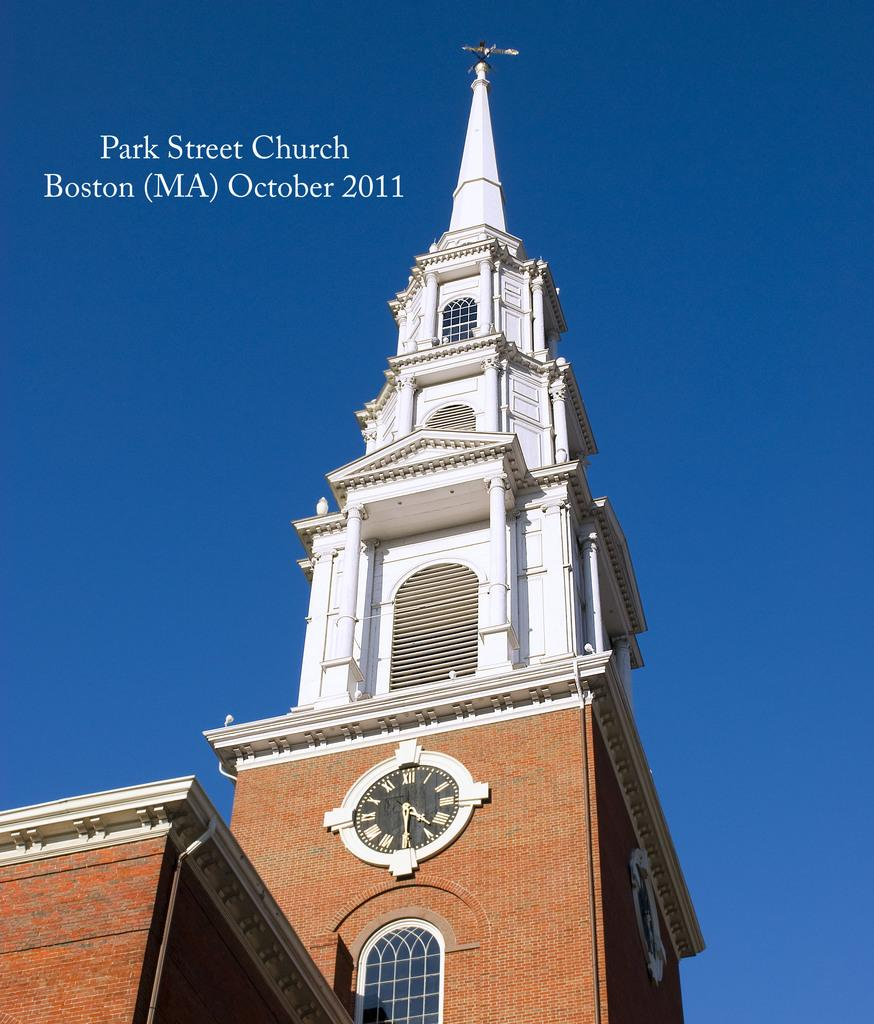<image>
Provide a brief description of the given image. A clock on the side of Park Street Church reads 4:30. 